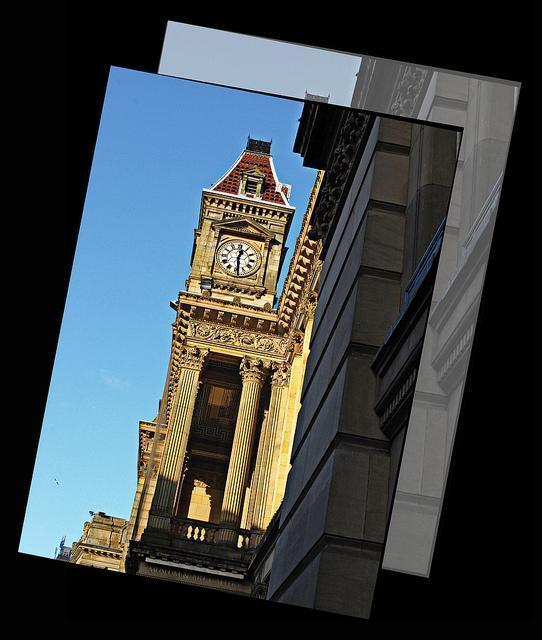How many laptops are shown?
Give a very brief answer. 0. 